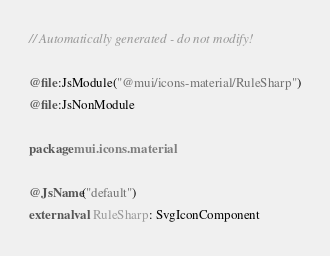<code> <loc_0><loc_0><loc_500><loc_500><_Kotlin_>// Automatically generated - do not modify!

@file:JsModule("@mui/icons-material/RuleSharp")
@file:JsNonModule

package mui.icons.material

@JsName("default")
external val RuleSharp: SvgIconComponent
</code> 